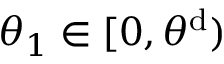<formula> <loc_0><loc_0><loc_500><loc_500>\theta _ { 1 } \in [ 0 , \theta ^ { d } )</formula> 